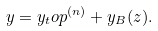Convert formula to latex. <formula><loc_0><loc_0><loc_500><loc_500>y = y _ { t } o p ^ { ( n ) } + y _ { B } ( z ) .</formula> 